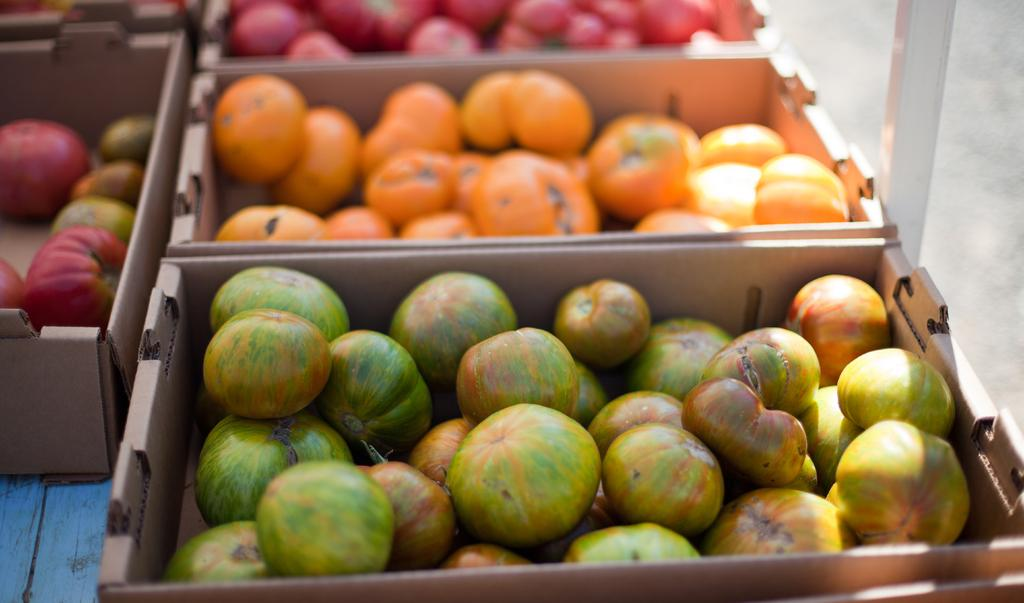What objects are present in the image? There are baskets in the image. What are the baskets holding? The baskets contain fruits. Can you describe any other elements in the image? There is a pole in the top right side of the image. How many servants can be seen attending to the baskets in the image? There are no servants present in the image. What type of bread is being served in the hall in the image? There is no bread or hall present in the image. 